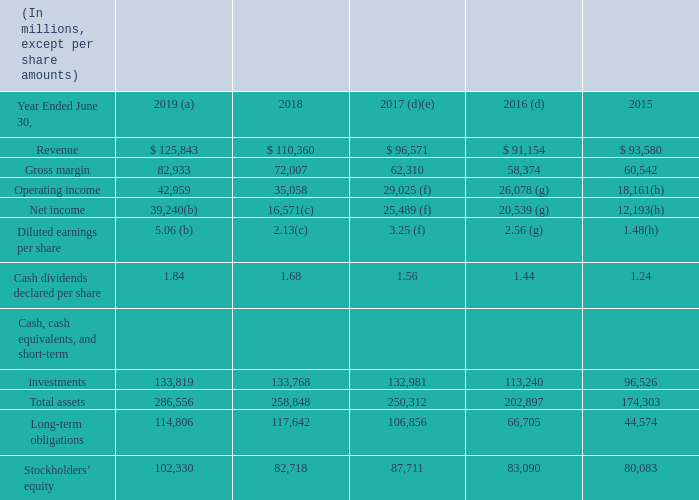(a) GitHub has been included in our consolidated results of operations starting on the October 25, 2018 acquisition date.
(b) Includes a $2.6 billion net income tax benefit related to intangible property transfers and a $157 million net charge related to the enactment of the Tax Cuts and Jobs Act (“TCJA”), which together increased net income and diluted earnings per share (“EPS”) by $2.4 billion and $0.31, respectively. Refer to Note 12 – Income Taxes of the Notes to Financial Statements for further discussion.
(c) Includes a $13.7 billion net charge related to the enactment of the TCJA, which decreased net income and diluted EPS by $13.7 billion and $1.75, respectively. Refer to Note 12 – Income Taxes of the Notes to Financial Statements for further discussion.
(d) Reflects the impact of the adoption of new accounting standards in fiscal year 2018 related to revenue recognition and leases.
(e) LinkedIn has been included in our consolidated results of operations starting on the December 8, 2016 acquisition date.
(f) Includes $306 million of employee severance expenses primarily related to our sales and marketing restructuring plan, which decreased operating income, net income, and diluted EPS by $306 million, $243 million, and $0.04, respectively.
(g) Includes $630 million of asset impairment charges related to our Phone business and $480 million of restructuring charges associated with our Phone business restructuring plans, which together decreased operating income, net income, and diluted EPS by $1.1 billion, $895 million, and $0.11, respectively.
(h) Includes $7.5 billion of goodwill and asset impairment charges related to our Phone business and $2.5 billion of integration and restructuring expenses, primarily associated with our Phone business restructuring plans, which together decreased operating income, net income, and diluted EPS by $10.0 billion, $9.5 billion, and $1.15, respectively.
Why did net income in 2018 decrease from that in 2017? Includes a $13.7 billion net charge related to the enactment of the tcja, which decreased net income and diluted eps by $13.7 billion and $1.75, respectively. How much would operating income in 2015 have been if there were no goodwill and impairment charges in 2015?
Answer scale should be: million. 10.0 billion + 18,161 million 
Answer: 28161. When was Linkedin acquired? December 8, 2016. When was GitHub acquired? October 25, 2018. What was the total liabilities in 2018?
Answer scale should be: million. 258,848-82,718
Answer: 176130. What was the average revenue over the 3 year period from 2017 to 2019?
Answer scale should be: million. (125,843+110,360+96,571)/(2019-2017+1)
Answer: 110924.67. 